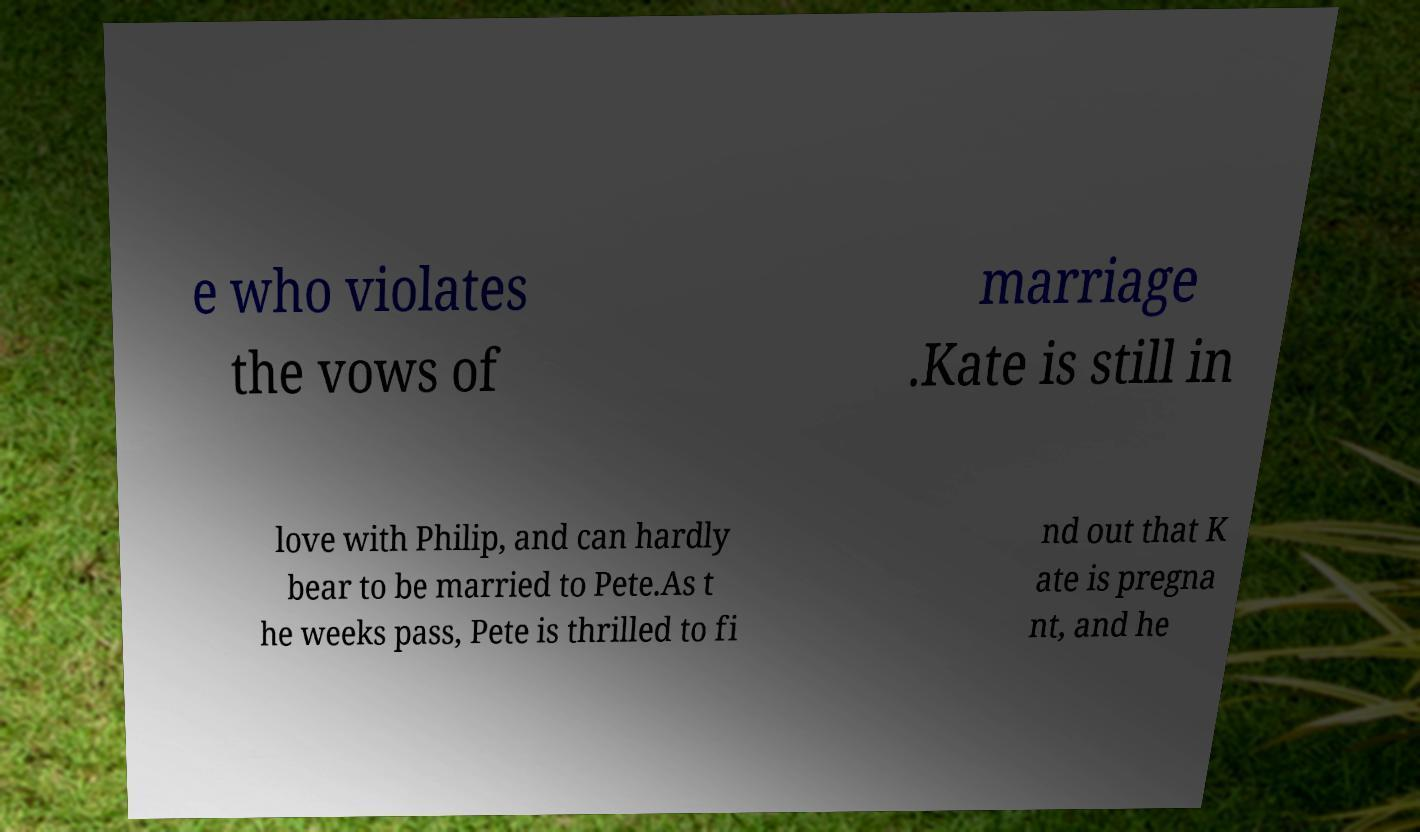Please identify and transcribe the text found in this image. e who violates the vows of marriage .Kate is still in love with Philip, and can hardly bear to be married to Pete.As t he weeks pass, Pete is thrilled to fi nd out that K ate is pregna nt, and he 